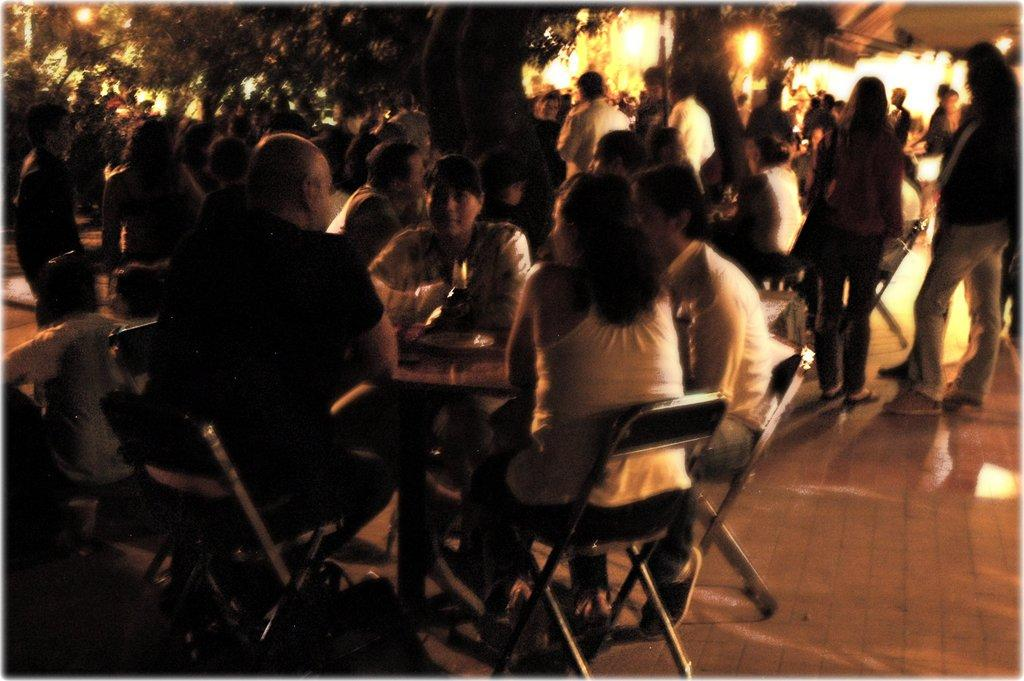What are the people in the image doing? The people in the image are sitting on chairs. Can you describe the background of the image? There are persons in the background of the image. What can be seen at the top of the image? Trees are visible at the top of the image. What type of fear can be seen on the faces of the cattle in the image? There are no cattle present in the image, so it is not possible to determine if they are experiencing any fear. 